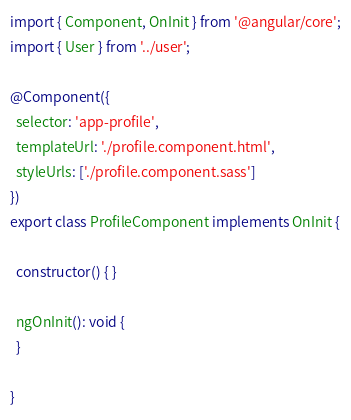<code> <loc_0><loc_0><loc_500><loc_500><_TypeScript_>import { Component, OnInit } from '@angular/core';
import { User } from '../user';

@Component({
  selector: 'app-profile',
  templateUrl: './profile.component.html',
  styleUrls: ['./profile.component.sass']
})
export class ProfileComponent implements OnInit {

  constructor() { }

  ngOnInit(): void {
  }

}
</code> 